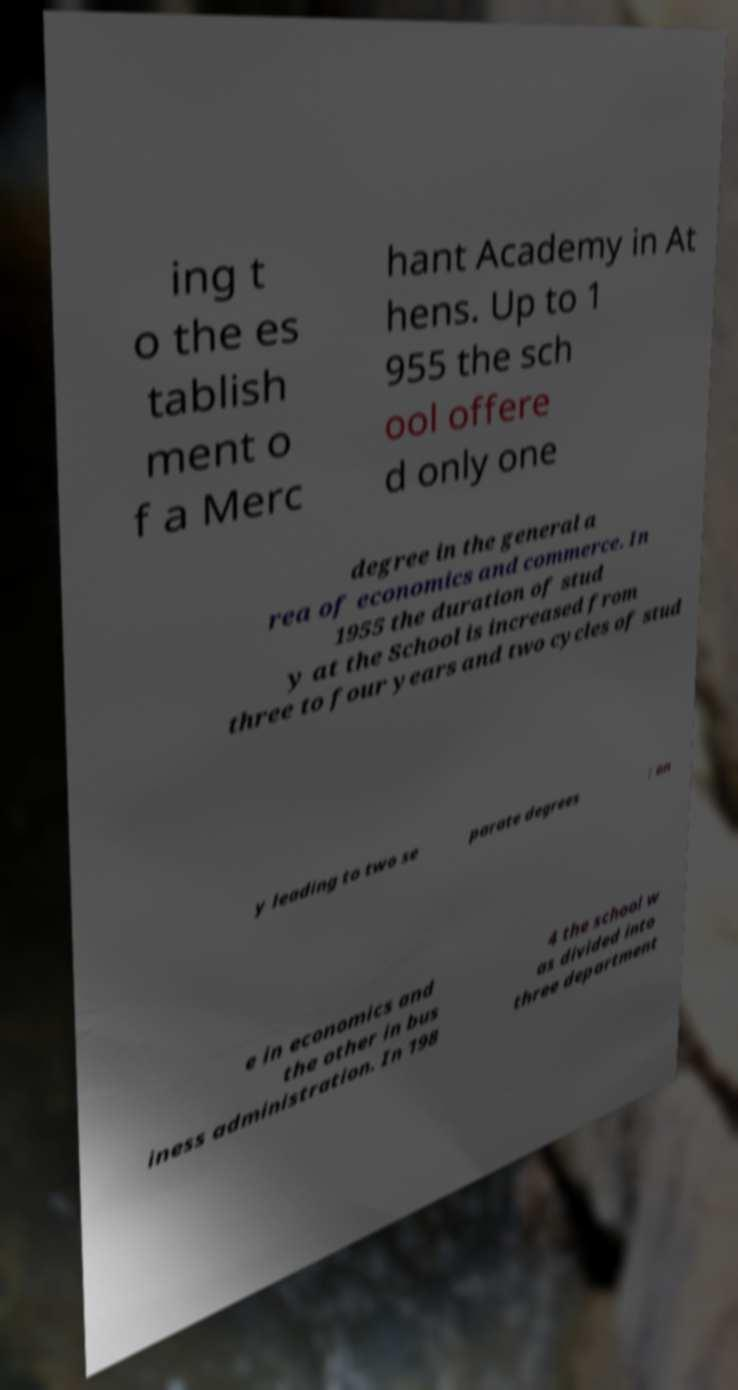Can you read and provide the text displayed in the image?This photo seems to have some interesting text. Can you extract and type it out for me? ing t o the es tablish ment o f a Merc hant Academy in At hens. Up to 1 955 the sch ool offere d only one degree in the general a rea of economics and commerce. In 1955 the duration of stud y at the School is increased from three to four years and two cycles of stud y leading to two se parate degrees : on e in economics and the other in bus iness administration. In 198 4 the school w as divided into three department 